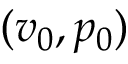Convert formula to latex. <formula><loc_0><loc_0><loc_500><loc_500>( v _ { 0 } , p _ { 0 } )</formula> 